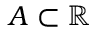<formula> <loc_0><loc_0><loc_500><loc_500>A \subset \mathbb { R }</formula> 